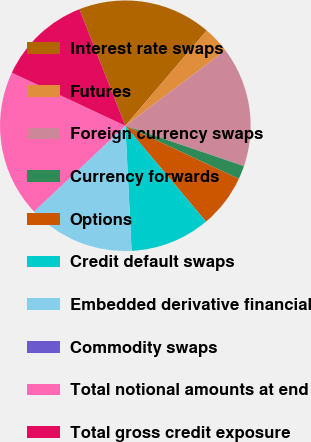<chart> <loc_0><loc_0><loc_500><loc_500><pie_chart><fcel>Interest rate swaps<fcel>Futures<fcel>Foreign currency swaps<fcel>Currency forwards<fcel>Options<fcel>Credit default swaps<fcel>Embedded derivative financial<fcel>Commodity swaps<fcel>Total notional amounts at end<fcel>Total gross credit exposure<nl><fcel>17.23%<fcel>3.46%<fcel>15.51%<fcel>1.74%<fcel>6.9%<fcel>10.34%<fcel>13.79%<fcel>0.02%<fcel>18.95%<fcel>12.07%<nl></chart> 